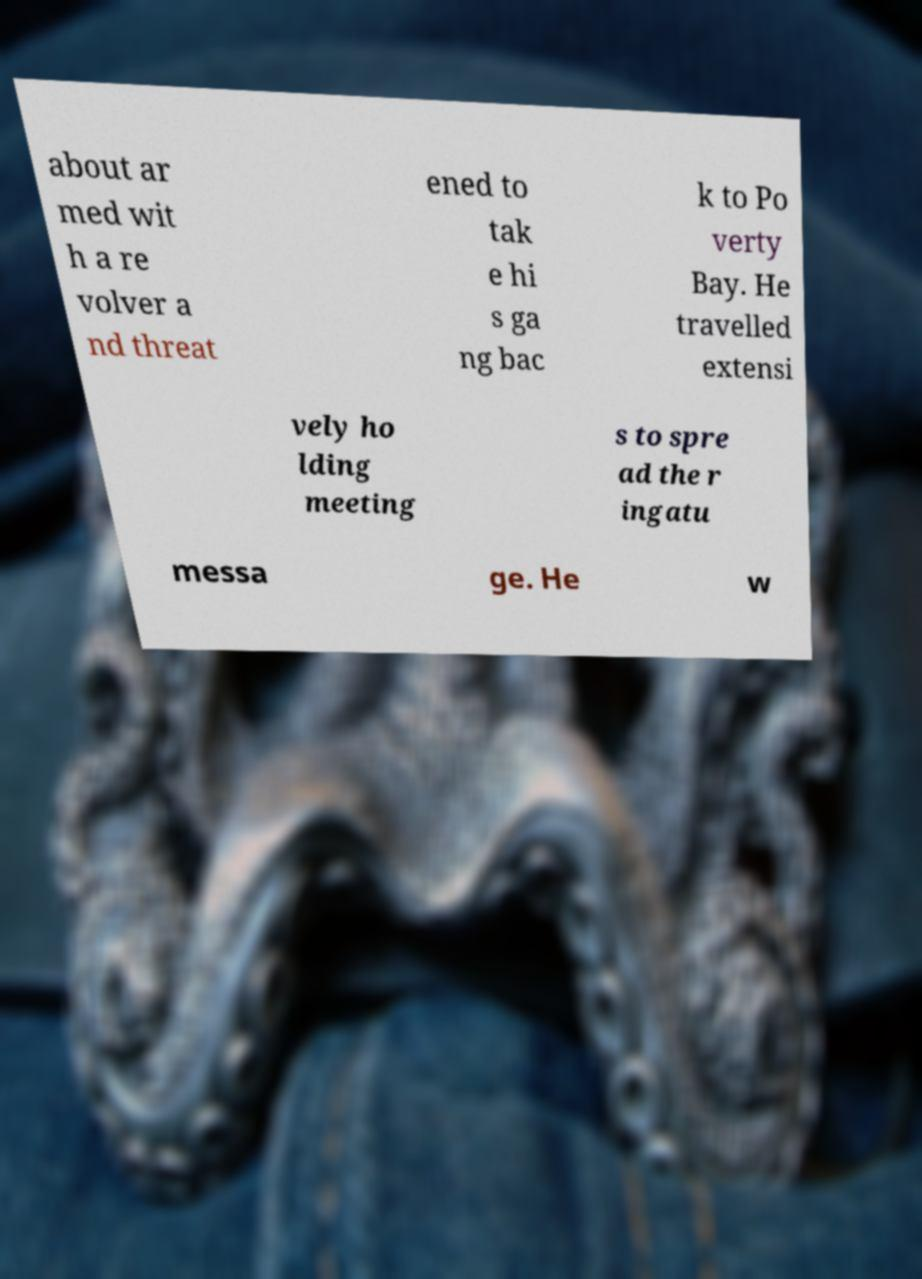For documentation purposes, I need the text within this image transcribed. Could you provide that? about ar med wit h a re volver a nd threat ened to tak e hi s ga ng bac k to Po verty Bay. He travelled extensi vely ho lding meeting s to spre ad the r ingatu messa ge. He w 